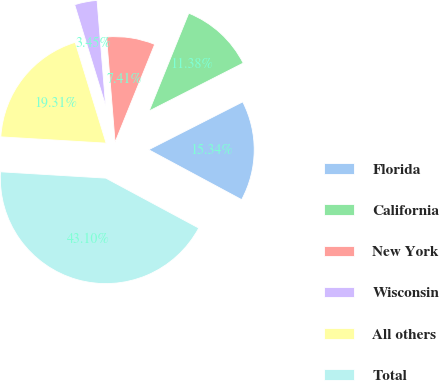Convert chart. <chart><loc_0><loc_0><loc_500><loc_500><pie_chart><fcel>Florida<fcel>California<fcel>New York<fcel>Wisconsin<fcel>All others<fcel>Total<nl><fcel>15.34%<fcel>11.38%<fcel>7.41%<fcel>3.45%<fcel>19.31%<fcel>43.1%<nl></chart> 